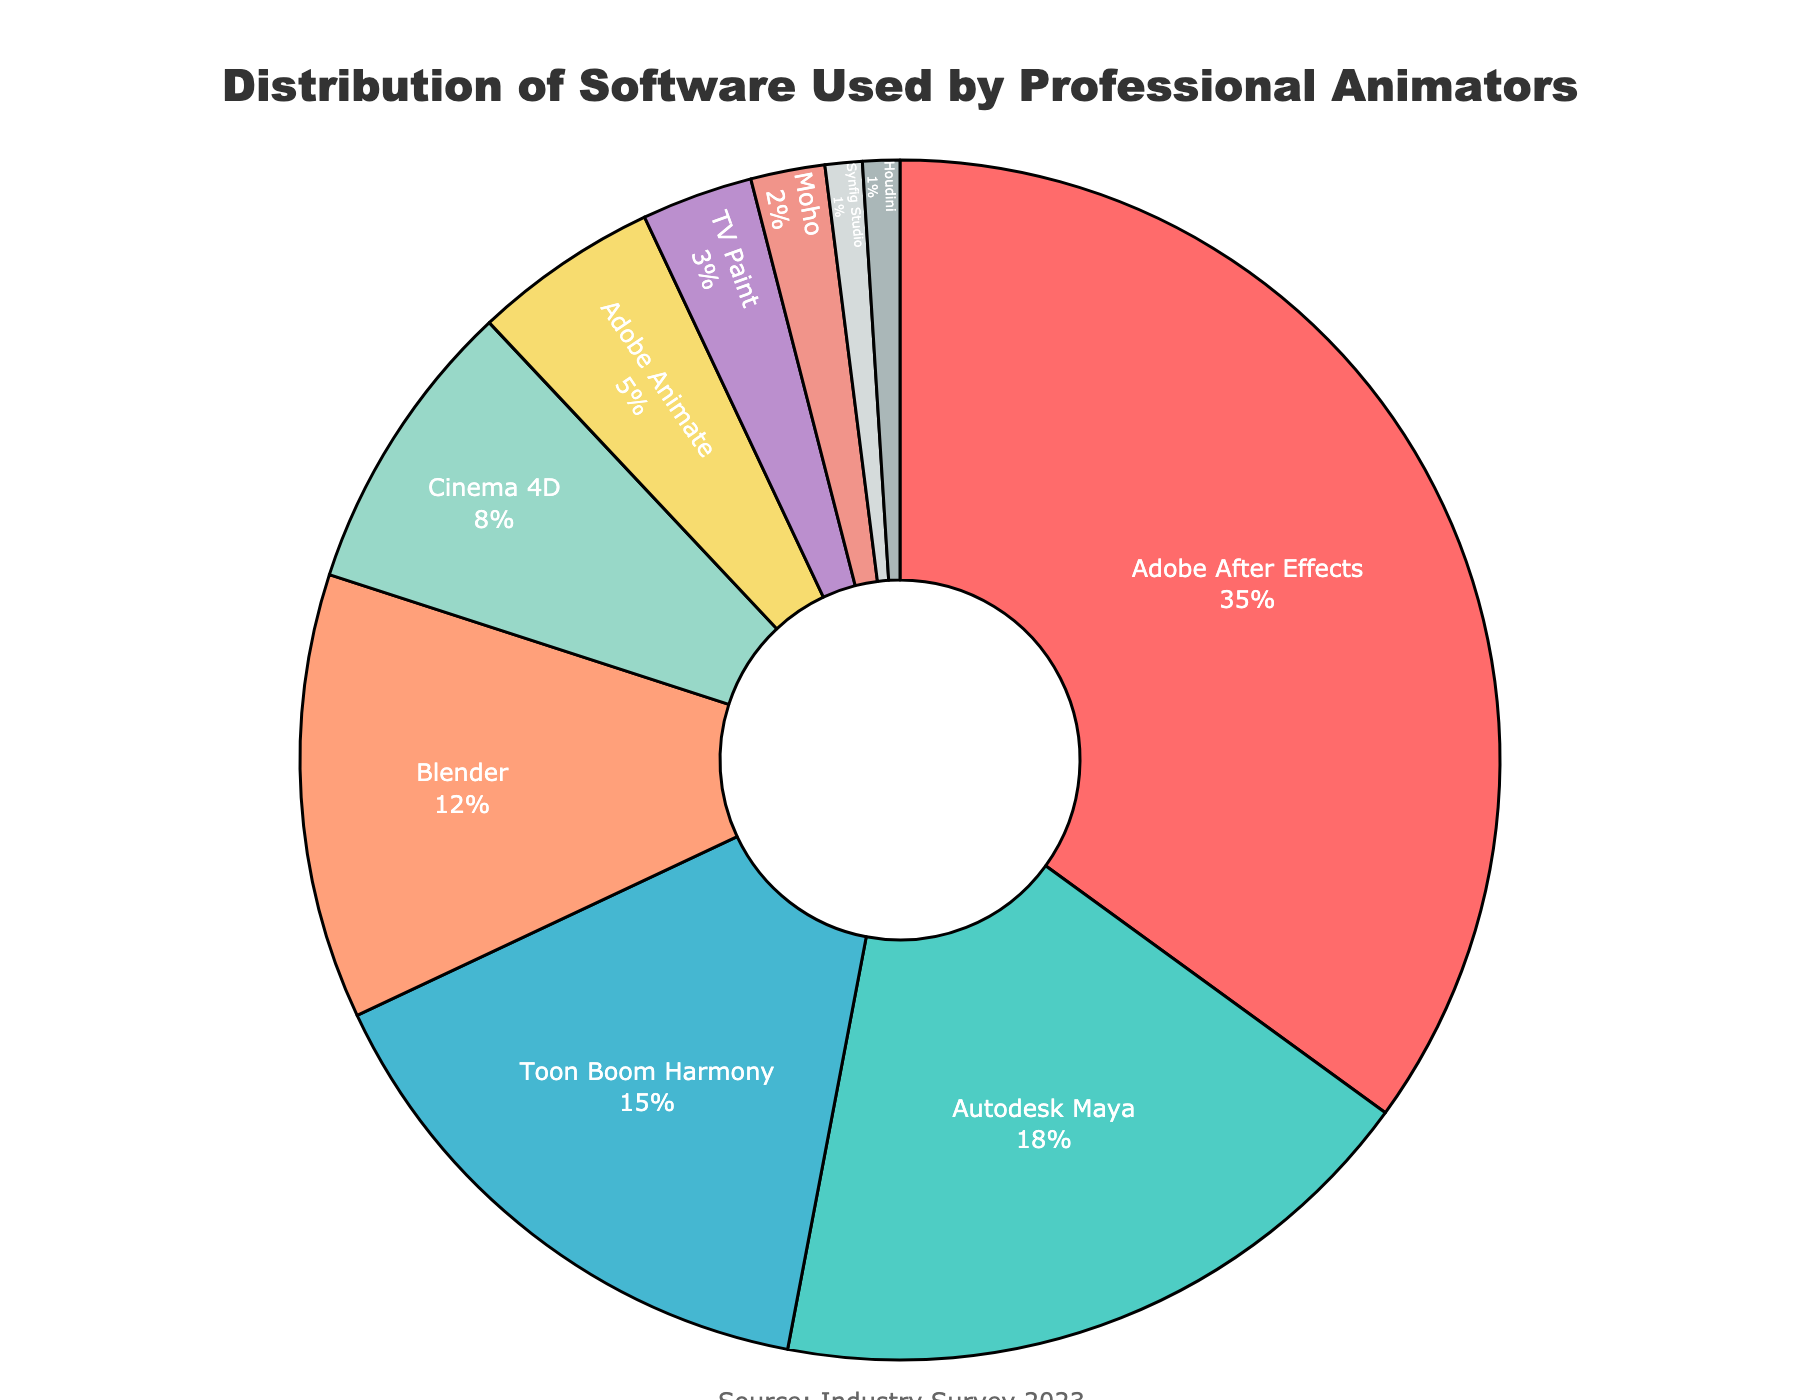What is the percentage of professional animators using Autodesk Maya? Find Autodesk Maya in the list and refer to its associated percentage value on the pie chart.
Answer: 18% Which software is used the most by professional animators? Identify the software with the largest slice in the pie chart, which corresponds to the highest percentage.
Answer: Adobe After Effects How much more popular is Adobe After Effects compared to Blender? Subtract Blender's percentage from Adobe After Effect's percentage (35% - 12%).
Answer: 23% What is the combined percentage of professional animators using Toon Boom Harmony and Cinema 4D? Add the percentages of Toon Boom Harmony and Cinema 4D (15% + 8%).
Answer: 23% Which two software have the smallest usage percentages, and what are their combined percentage? Identify the two smallest slices in the pie chart and sum their percentages (Synfig Studio and Houdini, with 1% each).
Answer: 2% Is Toon Boom Harmony used more than Blender, and if so, by how much? Compare the percentages of Toon Boom Harmony and Blender (15% and 12%). Subtract Blender's percentage from Toon Boom Harmony's (15% - 12%).
Answer: Yes, by 3% Which software are used by more than 10% of professional animators? Identify the software with slices representing percentages above 10% (Adobe After Effects, Autodesk Maya, Toon Boom Harmony, and Blender).
Answer: Adobe After Effects, Autodesk Maya, Toon Boom Harmony, Blender What is the percentage difference between the most and the least used software? Subtract the percentage of the least used software (1%) from the percentage of the most used one (35%) (35% - 1%).
Answer: 34% Among the software used, which ones have a percentage between 10% and 20%? List the software that fall within the 10%-20% range as shown in the pie chart percentages (Autodesk Maya and Toon Boom Harmony).
Answer: Autodesk Maya, Toon Boom Harmony 